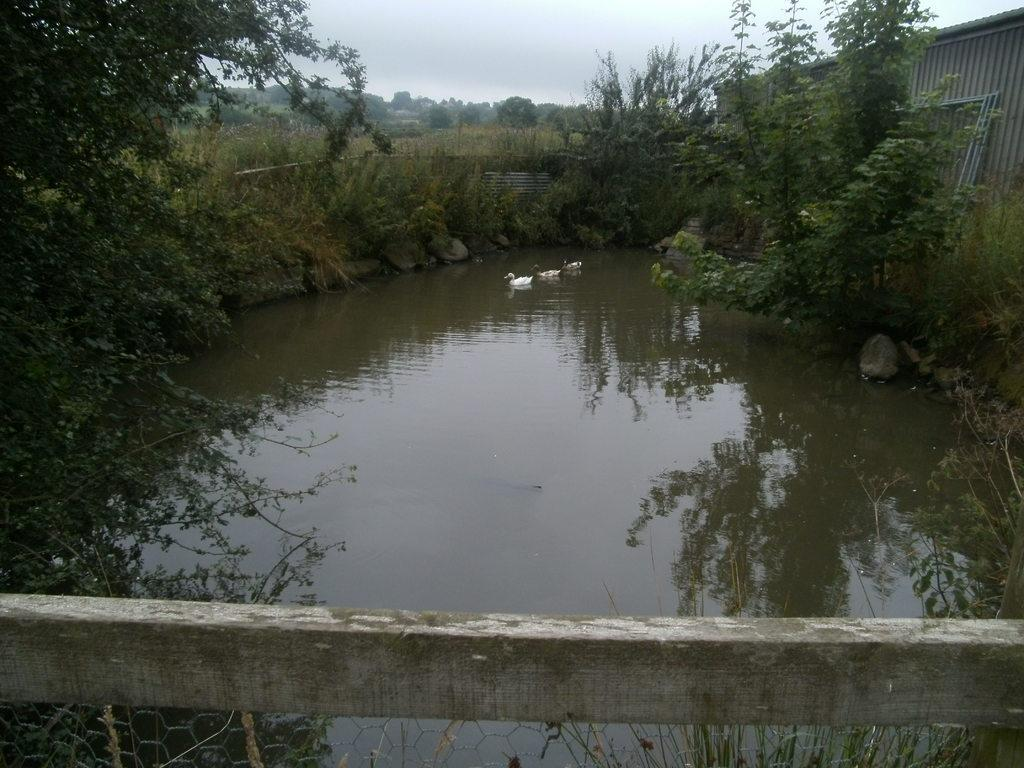What animals can be seen in the image? There are ducks in the image. What are the ducks doing in the image? The ducks are swimming on the water. What type of vegetation is visible in the image? There is grass visible in the image. What else can be seen in the image besides the ducks and grass? There are trees in the image. What type of teeth can be seen on the canvas in the image? There is no canvas or teeth present in the image. The image features ducks swimming on the water, surrounded by grass and trees. 